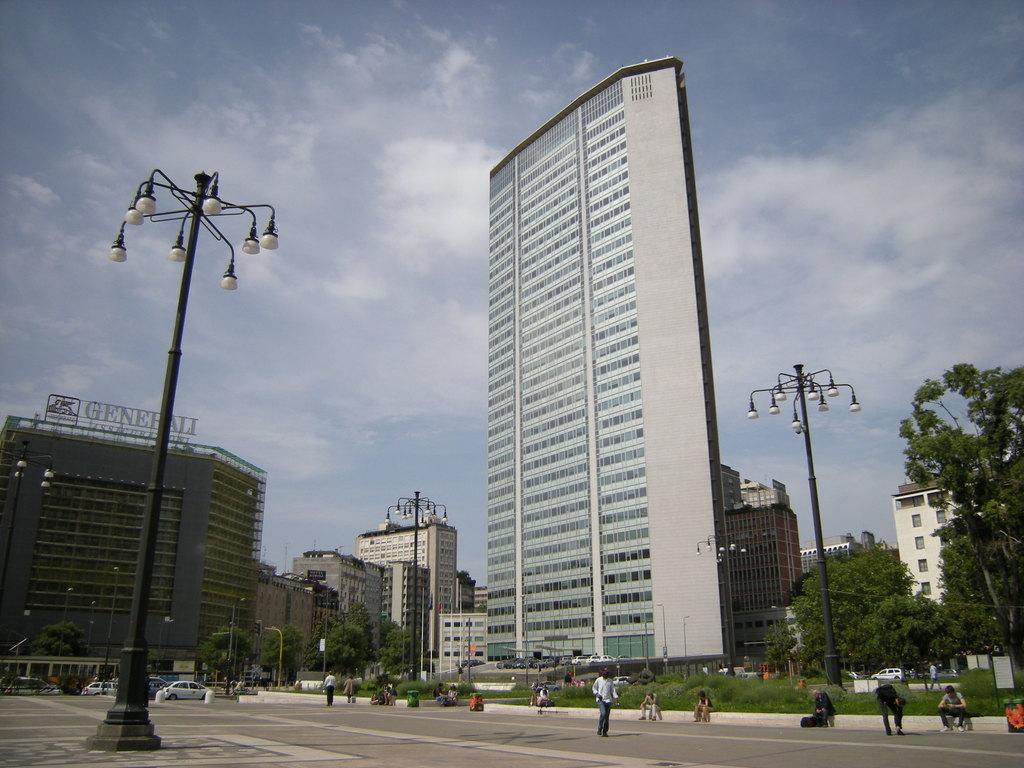Describe this image in one or two sentences. In this image there are buildings, street lights, poles, trees, plants, grass, vehicles are moving on the road and few people are walking, standing and sitting on the road. In the background there is the sky. 